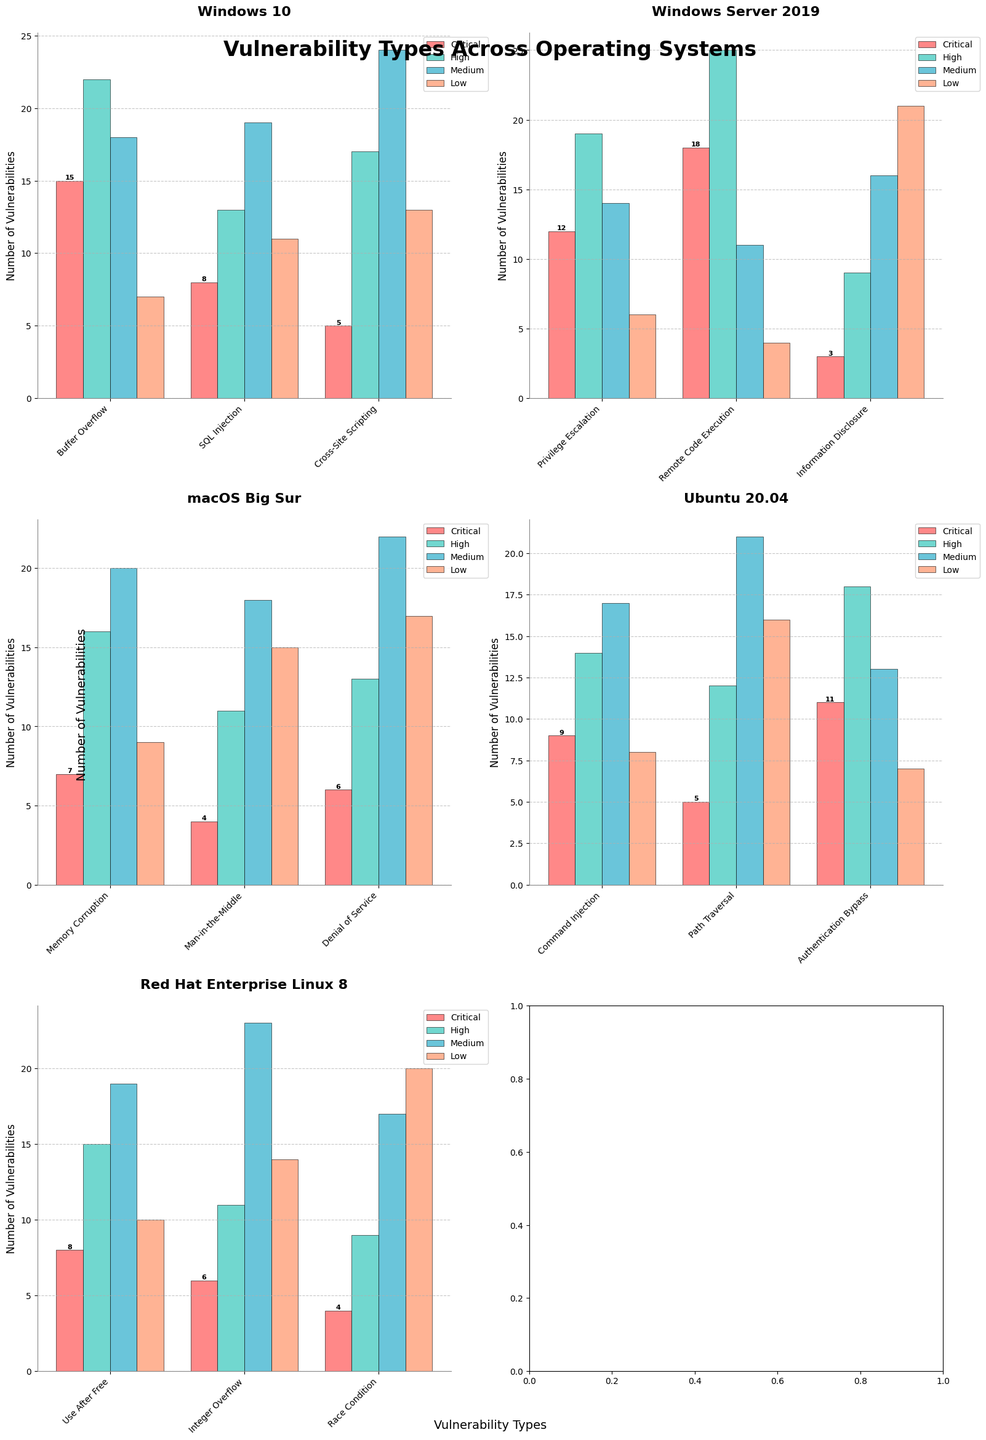Which operating system has the highest number of critical vulnerabilities for any single vulnerability type? The bar for "Remote Code Execution" under Windows Server 2019 shows the highest critical count, which is 18.
Answer: Windows Server 2019 What is the total number of medium vulnerabilities across all types for Ubuntu 20.04? Sum the "Medium" counts for vulnerabilities in Ubuntu 20.04: Command Injection (17) + Path Traversal (21) + Authentication Bypass (13) = 51.
Answer: 51 How many more high vulnerabilities does Windows Server 2019 have for "Remote Code Execution" compared to "Privilege Escalation"? The number of high vulnerabilities for Remote Code Execution is 25, and for Privilege Escalation it is 19. The difference is 25 - 19 = 6.
Answer: 6 Which vulnerability type in macOS Big Sur has the most low-level vulnerabilities? The "Denial of Service" vulnerability type has the highest count of low-level vulnerabilities, with 17.
Answer: Denial of Service What is the average number of critical vulnerabilities for "Buffer Overflow" and "SQL Injection" in Windows 10? The counts for critical vulnerabilities are 15 (Buffer Overflow) and 8 (SQL Injection). The average is (15 + 8) / 2 = 11.5.
Answer: 11.5 Which operating system has the most even distribution of vulnerabilities across all severity levels? By observing the consistency in the height of bars across all severity for each vulnerability type, it seems that Red Hat Enterprise Linux 8 has a relatively even distribution.
Answer: Red Hat Enterprise Linux 8 How many total vulnerabilities of high severity does macOS Big Sur have? Sum the "High" counts for vulnerabilities in macOS Big Sur: Memory Corruption (16) + Man-in-the-Middle (11) + Denial of Service (13) = 40.
Answer: 40 Compare the total number of low-level vulnerabilities between Windows 10 and Ubuntu 20.04. Which one has more, and by how much? Total low vulnerabilities for Windows 10: Buffer Overflow (7) + SQL Injection (11) + Cross-Site Scripting (13) = 31. Total for Ubuntu 20.04: Command Injection (8) + Path Traversal (16) + Authentication Bypass (7) = 31. Both have equal numbers.
Answer: Equal Does "Information Disclosure" in Windows Server 2019 have more medium vulnerabilities than "Race Condition" in Red Hat Enterprise Linux 8? For "Information Disclosure", the count is 16, and for "Race Condition", it is 17. Race Condition has more.
Answer: No What is the total number of vulnerabilities (all severities combined) for "Use After Free" in Red Hat Enterprise Linux 8? The counts for "Use After Free" are Critical (8) + High (15) + Medium (19) + Low (10) = 52.
Answer: 52 